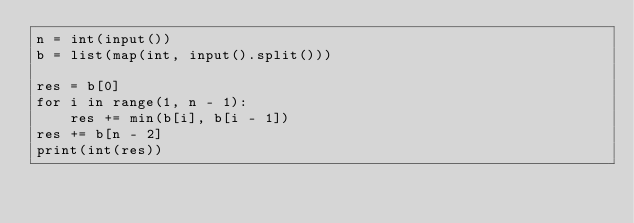Convert code to text. <code><loc_0><loc_0><loc_500><loc_500><_Python_>n = int(input())
b = list(map(int, input().split()))

res = b[0]
for i in range(1, n - 1):
    res += min(b[i], b[i - 1])
res += b[n - 2]
print(int(res))</code> 